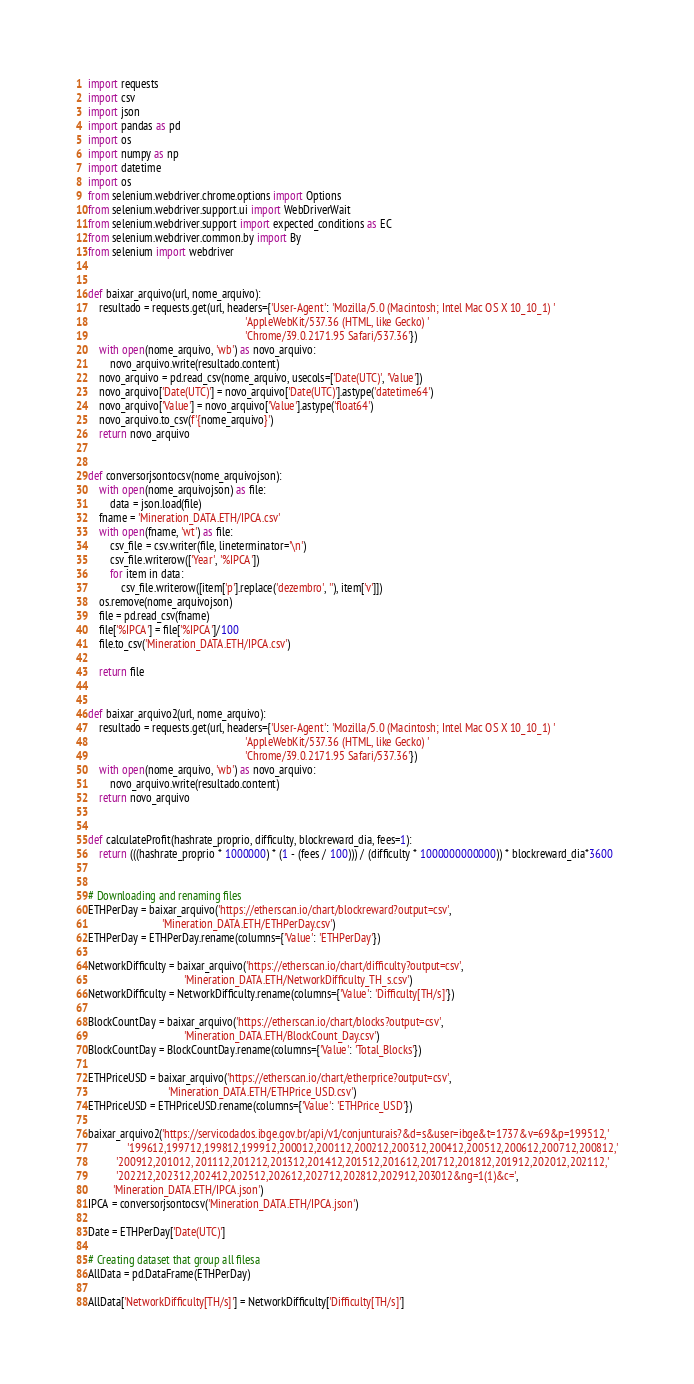<code> <loc_0><loc_0><loc_500><loc_500><_Python_>import requests
import csv
import json
import pandas as pd
import os
import numpy as np
import datetime
import os
from selenium.webdriver.chrome.options import Options
from selenium.webdriver.support.ui import WebDriverWait
from selenium.webdriver.support import expected_conditions as EC
from selenium.webdriver.common.by import By
from selenium import webdriver


def baixar_arquivo(url, nome_arquivo):
    resultado = requests.get(url, headers={'User-Agent': 'Mozilla/5.0 (Macintosh; Intel Mac OS X 10_10_1) '
                                                         'AppleWebKit/537.36 (HTML, like Gecko) '
                                                         'Chrome/39.0.2171.95 Safari/537.36'})
    with open(nome_arquivo, 'wb') as novo_arquivo:
        novo_arquivo.write(resultado.content)
    novo_arquivo = pd.read_csv(nome_arquivo, usecols=['Date(UTC)', 'Value'])
    novo_arquivo['Date(UTC)'] = novo_arquivo['Date(UTC)'].astype('datetime64')
    novo_arquivo['Value'] = novo_arquivo['Value'].astype('float64')
    novo_arquivo.to_csv(f'{nome_arquivo}')
    return novo_arquivo


def conversorjsontocsv(nome_arquivojson):
    with open(nome_arquivojson) as file:
        data = json.load(file)
    fname = 'Mineration_DATA.ETH/IPCA.csv'
    with open(fname, 'wt') as file:
        csv_file = csv.writer(file, lineterminator='\n')
        csv_file.writerow(['Year', '%IPCA'])
        for item in data:
            csv_file.writerow([item['p'].replace('dezembro', ''), item['v']])
    os.remove(nome_arquivojson)
    file = pd.read_csv(fname)
    file['%IPCA'] = file['%IPCA']/100
    file.to_csv('Mineration_DATA.ETH/IPCA.csv')

    return file


def baixar_arquivo2(url, nome_arquivo):
    resultado = requests.get(url, headers={'User-Agent': 'Mozilla/5.0 (Macintosh; Intel Mac OS X 10_10_1) '
                                                         'AppleWebKit/537.36 (HTML, like Gecko) '
                                                         'Chrome/39.0.2171.95 Safari/537.36'})
    with open(nome_arquivo, 'wb') as novo_arquivo:
        novo_arquivo.write(resultado.content)
    return novo_arquivo


def calculateProfit(hashrate_proprio, difficulty, blockreward_dia, fees=1):
    return (((hashrate_proprio * 1000000) * (1 - (fees / 100))) / (difficulty * 1000000000000)) * blockreward_dia*3600


# Downloading and renaming files
ETHPerDay = baixar_arquivo('https://etherscan.io/chart/blockreward?output=csv',
                           'Mineration_DATA.ETH/ETHPerDay.csv')
ETHPerDay = ETHPerDay.rename(columns={'Value': 'ETHPerDay'})

NetworkDifficulty = baixar_arquivo('https://etherscan.io/chart/difficulty?output=csv',
                                   'Mineration_DATA.ETH/NetworkDifficulty_TH_s.csv')
NetworkDifficulty = NetworkDifficulty.rename(columns={'Value': 'Difficulty[TH/s]'})

BlockCountDay = baixar_arquivo('https://etherscan.io/chart/blocks?output=csv',
                                   'Mineration_DATA.ETH/BlockCount_Day.csv')
BlockCountDay = BlockCountDay.rename(columns={'Value': 'Total_Blocks'})

ETHPriceUSD = baixar_arquivo('https://etherscan.io/chart/etherprice?output=csv',
                             'Mineration_DATA.ETH/ETHPrice_USD.csv')
ETHPriceUSD = ETHPriceUSD.rename(columns={'Value': 'ETHPrice_USD'})

baixar_arquivo2('https://servicodados.ibge.gov.br/api/v1/conjunturais?&d=s&user=ibge&t=1737&v=69&p=199512,'
              '199612,199712,199812,199912,200012,200112,200212,200312,200412,200512,200612,200712,200812,'
          '200912,201012, 201112,201212,201312,201412,201512,201612,201712,201812,201912,202012,202112,'
          '202212,202312,202412,202512,202612,202712,202812,202912,203012&ng=1(1)&c=',
         'Mineration_DATA.ETH/IPCA.json')
IPCA = conversorjsontocsv('Mineration_DATA.ETH/IPCA.json')

Date = ETHPerDay['Date(UTC)']

# Creating dataset that group all filesa
AllData = pd.DataFrame(ETHPerDay)

AllData['NetworkDifficulty[TH/s]'] = NetworkDifficulty['Difficulty[TH/s]']
</code> 